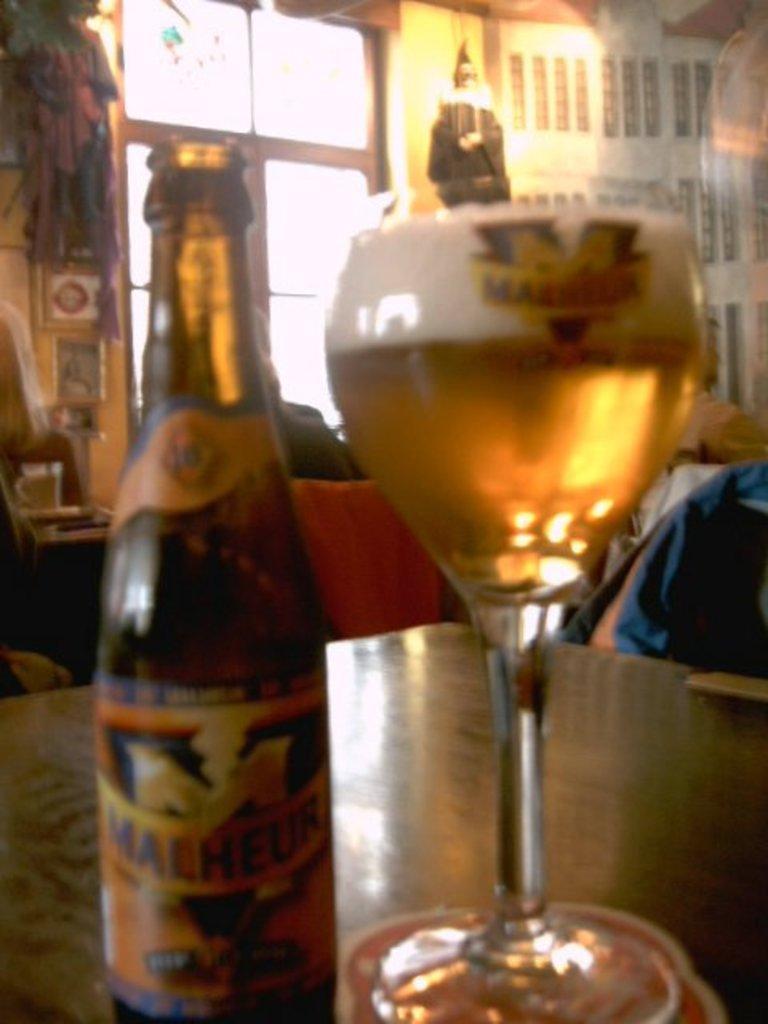Please provide a concise description of this image. The picture consists of beer bottle beside a wine glass on a table,this seems to be in a room, on the background wall there is a table, it looks like there is a person over to the right side. 